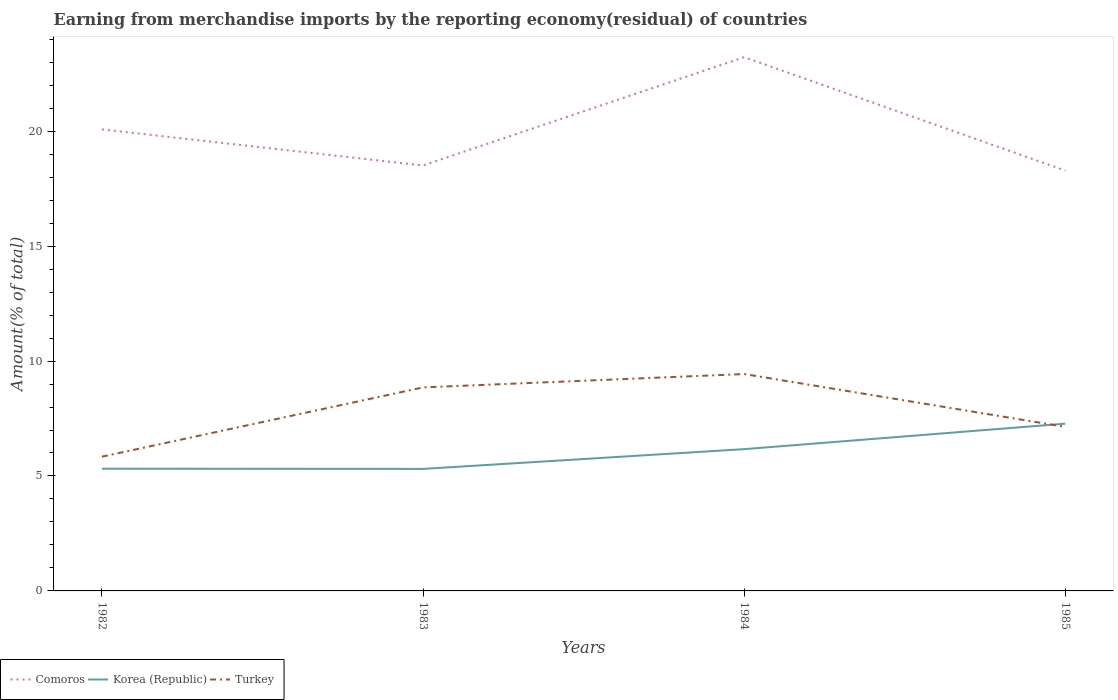Is the number of lines equal to the number of legend labels?
Provide a short and direct response. Yes. Across all years, what is the maximum percentage of amount earned from merchandise imports in Korea (Republic)?
Offer a very short reply. 5.31. What is the total percentage of amount earned from merchandise imports in Comoros in the graph?
Provide a short and direct response. -4.71. What is the difference between the highest and the second highest percentage of amount earned from merchandise imports in Korea (Republic)?
Give a very brief answer. 1.97. Is the percentage of amount earned from merchandise imports in Comoros strictly greater than the percentage of amount earned from merchandise imports in Turkey over the years?
Keep it short and to the point. No. Are the values on the major ticks of Y-axis written in scientific E-notation?
Provide a short and direct response. No. How many legend labels are there?
Provide a succinct answer. 3. What is the title of the graph?
Your answer should be very brief. Earning from merchandise imports by the reporting economy(residual) of countries. What is the label or title of the Y-axis?
Ensure brevity in your answer.  Amount(% of total). What is the Amount(% of total) of Comoros in 1982?
Provide a succinct answer. 20.08. What is the Amount(% of total) of Korea (Republic) in 1982?
Provide a succinct answer. 5.32. What is the Amount(% of total) in Turkey in 1982?
Provide a succinct answer. 5.84. What is the Amount(% of total) of Comoros in 1983?
Your answer should be very brief. 18.51. What is the Amount(% of total) of Korea (Republic) in 1983?
Offer a very short reply. 5.31. What is the Amount(% of total) of Turkey in 1983?
Your answer should be compact. 8.85. What is the Amount(% of total) in Comoros in 1984?
Provide a short and direct response. 23.22. What is the Amount(% of total) of Korea (Republic) in 1984?
Offer a very short reply. 6.17. What is the Amount(% of total) of Turkey in 1984?
Offer a terse response. 9.43. What is the Amount(% of total) in Comoros in 1985?
Provide a short and direct response. 18.29. What is the Amount(% of total) in Korea (Republic) in 1985?
Make the answer very short. 7.28. What is the Amount(% of total) in Turkey in 1985?
Provide a short and direct response. 7.14. Across all years, what is the maximum Amount(% of total) in Comoros?
Your answer should be very brief. 23.22. Across all years, what is the maximum Amount(% of total) of Korea (Republic)?
Make the answer very short. 7.28. Across all years, what is the maximum Amount(% of total) of Turkey?
Keep it short and to the point. 9.43. Across all years, what is the minimum Amount(% of total) of Comoros?
Your answer should be compact. 18.29. Across all years, what is the minimum Amount(% of total) in Korea (Republic)?
Provide a short and direct response. 5.31. Across all years, what is the minimum Amount(% of total) in Turkey?
Offer a very short reply. 5.84. What is the total Amount(% of total) of Comoros in the graph?
Provide a short and direct response. 80.09. What is the total Amount(% of total) in Korea (Republic) in the graph?
Make the answer very short. 24.07. What is the total Amount(% of total) of Turkey in the graph?
Provide a short and direct response. 31.26. What is the difference between the Amount(% of total) in Comoros in 1982 and that in 1983?
Your response must be concise. 1.57. What is the difference between the Amount(% of total) of Korea (Republic) in 1982 and that in 1983?
Your response must be concise. 0.01. What is the difference between the Amount(% of total) of Turkey in 1982 and that in 1983?
Keep it short and to the point. -3.01. What is the difference between the Amount(% of total) in Comoros in 1982 and that in 1984?
Provide a succinct answer. -3.14. What is the difference between the Amount(% of total) of Korea (Republic) in 1982 and that in 1984?
Your answer should be very brief. -0.85. What is the difference between the Amount(% of total) in Turkey in 1982 and that in 1984?
Your answer should be compact. -3.6. What is the difference between the Amount(% of total) of Comoros in 1982 and that in 1985?
Provide a short and direct response. 1.79. What is the difference between the Amount(% of total) of Korea (Republic) in 1982 and that in 1985?
Your answer should be compact. -1.96. What is the difference between the Amount(% of total) of Turkey in 1982 and that in 1985?
Ensure brevity in your answer.  -1.3. What is the difference between the Amount(% of total) of Comoros in 1983 and that in 1984?
Your response must be concise. -4.71. What is the difference between the Amount(% of total) in Korea (Republic) in 1983 and that in 1984?
Ensure brevity in your answer.  -0.86. What is the difference between the Amount(% of total) in Turkey in 1983 and that in 1984?
Your answer should be compact. -0.58. What is the difference between the Amount(% of total) of Comoros in 1983 and that in 1985?
Your answer should be very brief. 0.22. What is the difference between the Amount(% of total) in Korea (Republic) in 1983 and that in 1985?
Your answer should be compact. -1.97. What is the difference between the Amount(% of total) in Turkey in 1983 and that in 1985?
Your answer should be very brief. 1.72. What is the difference between the Amount(% of total) in Comoros in 1984 and that in 1985?
Provide a short and direct response. 4.93. What is the difference between the Amount(% of total) in Korea (Republic) in 1984 and that in 1985?
Ensure brevity in your answer.  -1.11. What is the difference between the Amount(% of total) in Turkey in 1984 and that in 1985?
Offer a terse response. 2.3. What is the difference between the Amount(% of total) in Comoros in 1982 and the Amount(% of total) in Korea (Republic) in 1983?
Provide a succinct answer. 14.77. What is the difference between the Amount(% of total) in Comoros in 1982 and the Amount(% of total) in Turkey in 1983?
Provide a short and direct response. 11.22. What is the difference between the Amount(% of total) of Korea (Republic) in 1982 and the Amount(% of total) of Turkey in 1983?
Your answer should be very brief. -3.54. What is the difference between the Amount(% of total) in Comoros in 1982 and the Amount(% of total) in Korea (Republic) in 1984?
Make the answer very short. 13.91. What is the difference between the Amount(% of total) in Comoros in 1982 and the Amount(% of total) in Turkey in 1984?
Provide a succinct answer. 10.64. What is the difference between the Amount(% of total) in Korea (Republic) in 1982 and the Amount(% of total) in Turkey in 1984?
Your answer should be compact. -4.12. What is the difference between the Amount(% of total) in Comoros in 1982 and the Amount(% of total) in Korea (Republic) in 1985?
Ensure brevity in your answer.  12.8. What is the difference between the Amount(% of total) of Comoros in 1982 and the Amount(% of total) of Turkey in 1985?
Your response must be concise. 12.94. What is the difference between the Amount(% of total) of Korea (Republic) in 1982 and the Amount(% of total) of Turkey in 1985?
Keep it short and to the point. -1.82. What is the difference between the Amount(% of total) of Comoros in 1983 and the Amount(% of total) of Korea (Republic) in 1984?
Your answer should be very brief. 12.34. What is the difference between the Amount(% of total) of Comoros in 1983 and the Amount(% of total) of Turkey in 1984?
Your response must be concise. 9.07. What is the difference between the Amount(% of total) of Korea (Republic) in 1983 and the Amount(% of total) of Turkey in 1984?
Provide a short and direct response. -4.13. What is the difference between the Amount(% of total) in Comoros in 1983 and the Amount(% of total) in Korea (Republic) in 1985?
Your answer should be compact. 11.23. What is the difference between the Amount(% of total) of Comoros in 1983 and the Amount(% of total) of Turkey in 1985?
Give a very brief answer. 11.37. What is the difference between the Amount(% of total) in Korea (Republic) in 1983 and the Amount(% of total) in Turkey in 1985?
Provide a succinct answer. -1.83. What is the difference between the Amount(% of total) in Comoros in 1984 and the Amount(% of total) in Korea (Republic) in 1985?
Provide a succinct answer. 15.94. What is the difference between the Amount(% of total) of Comoros in 1984 and the Amount(% of total) of Turkey in 1985?
Provide a short and direct response. 16.08. What is the difference between the Amount(% of total) in Korea (Republic) in 1984 and the Amount(% of total) in Turkey in 1985?
Make the answer very short. -0.97. What is the average Amount(% of total) in Comoros per year?
Make the answer very short. 20.02. What is the average Amount(% of total) in Korea (Republic) per year?
Make the answer very short. 6.02. What is the average Amount(% of total) of Turkey per year?
Your answer should be compact. 7.82. In the year 1982, what is the difference between the Amount(% of total) of Comoros and Amount(% of total) of Korea (Republic)?
Keep it short and to the point. 14.76. In the year 1982, what is the difference between the Amount(% of total) in Comoros and Amount(% of total) in Turkey?
Offer a very short reply. 14.24. In the year 1982, what is the difference between the Amount(% of total) of Korea (Republic) and Amount(% of total) of Turkey?
Make the answer very short. -0.52. In the year 1983, what is the difference between the Amount(% of total) of Comoros and Amount(% of total) of Korea (Republic)?
Offer a terse response. 13.2. In the year 1983, what is the difference between the Amount(% of total) of Comoros and Amount(% of total) of Turkey?
Provide a short and direct response. 9.65. In the year 1983, what is the difference between the Amount(% of total) in Korea (Republic) and Amount(% of total) in Turkey?
Offer a terse response. -3.55. In the year 1984, what is the difference between the Amount(% of total) of Comoros and Amount(% of total) of Korea (Republic)?
Make the answer very short. 17.05. In the year 1984, what is the difference between the Amount(% of total) in Comoros and Amount(% of total) in Turkey?
Your answer should be compact. 13.78. In the year 1984, what is the difference between the Amount(% of total) of Korea (Republic) and Amount(% of total) of Turkey?
Your answer should be compact. -3.27. In the year 1985, what is the difference between the Amount(% of total) in Comoros and Amount(% of total) in Korea (Republic)?
Provide a succinct answer. 11.01. In the year 1985, what is the difference between the Amount(% of total) in Comoros and Amount(% of total) in Turkey?
Offer a very short reply. 11.15. In the year 1985, what is the difference between the Amount(% of total) of Korea (Republic) and Amount(% of total) of Turkey?
Give a very brief answer. 0.14. What is the ratio of the Amount(% of total) of Comoros in 1982 to that in 1983?
Keep it short and to the point. 1.08. What is the ratio of the Amount(% of total) of Korea (Republic) in 1982 to that in 1983?
Your response must be concise. 1. What is the ratio of the Amount(% of total) of Turkey in 1982 to that in 1983?
Keep it short and to the point. 0.66. What is the ratio of the Amount(% of total) of Comoros in 1982 to that in 1984?
Keep it short and to the point. 0.86. What is the ratio of the Amount(% of total) of Korea (Republic) in 1982 to that in 1984?
Make the answer very short. 0.86. What is the ratio of the Amount(% of total) of Turkey in 1982 to that in 1984?
Make the answer very short. 0.62. What is the ratio of the Amount(% of total) of Comoros in 1982 to that in 1985?
Your answer should be compact. 1.1. What is the ratio of the Amount(% of total) of Korea (Republic) in 1982 to that in 1985?
Make the answer very short. 0.73. What is the ratio of the Amount(% of total) of Turkey in 1982 to that in 1985?
Provide a succinct answer. 0.82. What is the ratio of the Amount(% of total) in Comoros in 1983 to that in 1984?
Offer a terse response. 0.8. What is the ratio of the Amount(% of total) of Korea (Republic) in 1983 to that in 1984?
Your answer should be very brief. 0.86. What is the ratio of the Amount(% of total) in Turkey in 1983 to that in 1984?
Offer a terse response. 0.94. What is the ratio of the Amount(% of total) of Comoros in 1983 to that in 1985?
Offer a very short reply. 1.01. What is the ratio of the Amount(% of total) in Korea (Republic) in 1983 to that in 1985?
Offer a very short reply. 0.73. What is the ratio of the Amount(% of total) in Turkey in 1983 to that in 1985?
Your answer should be compact. 1.24. What is the ratio of the Amount(% of total) in Comoros in 1984 to that in 1985?
Keep it short and to the point. 1.27. What is the ratio of the Amount(% of total) in Korea (Republic) in 1984 to that in 1985?
Your response must be concise. 0.85. What is the ratio of the Amount(% of total) in Turkey in 1984 to that in 1985?
Your answer should be compact. 1.32. What is the difference between the highest and the second highest Amount(% of total) in Comoros?
Give a very brief answer. 3.14. What is the difference between the highest and the second highest Amount(% of total) of Korea (Republic)?
Provide a succinct answer. 1.11. What is the difference between the highest and the second highest Amount(% of total) in Turkey?
Offer a very short reply. 0.58. What is the difference between the highest and the lowest Amount(% of total) of Comoros?
Provide a short and direct response. 4.93. What is the difference between the highest and the lowest Amount(% of total) of Korea (Republic)?
Your answer should be compact. 1.97. What is the difference between the highest and the lowest Amount(% of total) in Turkey?
Provide a succinct answer. 3.6. 